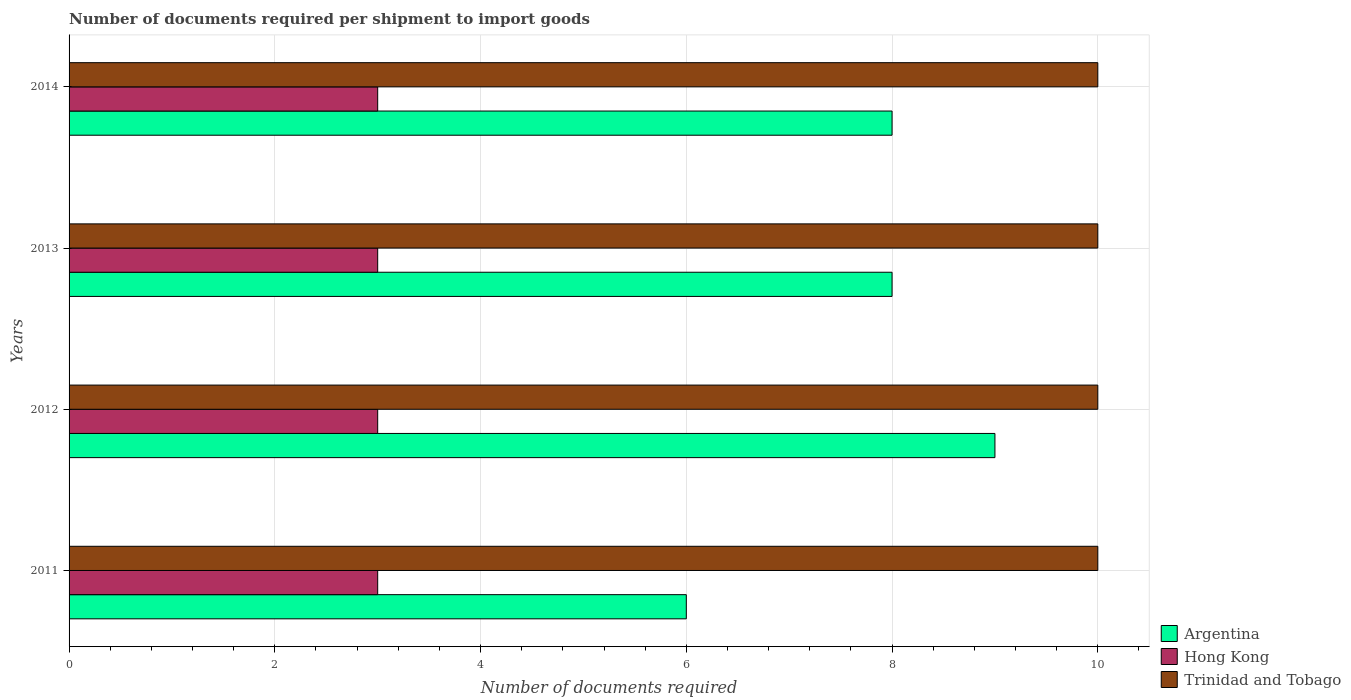How many different coloured bars are there?
Your answer should be compact. 3. Are the number of bars per tick equal to the number of legend labels?
Your answer should be very brief. Yes. Are the number of bars on each tick of the Y-axis equal?
Your answer should be compact. Yes. How many bars are there on the 1st tick from the top?
Your answer should be very brief. 3. In how many cases, is the number of bars for a given year not equal to the number of legend labels?
Offer a very short reply. 0. What is the number of documents required per shipment to import goods in Trinidad and Tobago in 2011?
Provide a succinct answer. 10. Across all years, what is the maximum number of documents required per shipment to import goods in Trinidad and Tobago?
Your answer should be very brief. 10. Across all years, what is the minimum number of documents required per shipment to import goods in Hong Kong?
Make the answer very short. 3. What is the total number of documents required per shipment to import goods in Hong Kong in the graph?
Your answer should be very brief. 12. What is the difference between the number of documents required per shipment to import goods in Hong Kong in 2012 and that in 2014?
Keep it short and to the point. 0. What is the difference between the number of documents required per shipment to import goods in Hong Kong in 2011 and the number of documents required per shipment to import goods in Argentina in 2012?
Your answer should be compact. -6. In the year 2014, what is the difference between the number of documents required per shipment to import goods in Argentina and number of documents required per shipment to import goods in Hong Kong?
Your answer should be compact. 5. Is the number of documents required per shipment to import goods in Trinidad and Tobago in 2012 less than that in 2013?
Make the answer very short. No. Is the difference between the number of documents required per shipment to import goods in Argentina in 2012 and 2014 greater than the difference between the number of documents required per shipment to import goods in Hong Kong in 2012 and 2014?
Offer a terse response. Yes. What is the difference between the highest and the lowest number of documents required per shipment to import goods in Trinidad and Tobago?
Offer a terse response. 0. In how many years, is the number of documents required per shipment to import goods in Hong Kong greater than the average number of documents required per shipment to import goods in Hong Kong taken over all years?
Give a very brief answer. 0. Is the sum of the number of documents required per shipment to import goods in Hong Kong in 2011 and 2012 greater than the maximum number of documents required per shipment to import goods in Trinidad and Tobago across all years?
Your response must be concise. No. What does the 1st bar from the bottom in 2011 represents?
Provide a short and direct response. Argentina. Is it the case that in every year, the sum of the number of documents required per shipment to import goods in Trinidad and Tobago and number of documents required per shipment to import goods in Argentina is greater than the number of documents required per shipment to import goods in Hong Kong?
Your answer should be very brief. Yes. Are all the bars in the graph horizontal?
Your answer should be compact. Yes. How are the legend labels stacked?
Your response must be concise. Vertical. What is the title of the graph?
Give a very brief answer. Number of documents required per shipment to import goods. What is the label or title of the X-axis?
Keep it short and to the point. Number of documents required. What is the Number of documents required in Hong Kong in 2011?
Provide a succinct answer. 3. What is the Number of documents required of Argentina in 2012?
Offer a very short reply. 9. What is the Number of documents required in Hong Kong in 2012?
Your response must be concise. 3. What is the Number of documents required in Trinidad and Tobago in 2012?
Keep it short and to the point. 10. What is the Number of documents required in Hong Kong in 2013?
Your answer should be very brief. 3. What is the Number of documents required of Trinidad and Tobago in 2013?
Your answer should be compact. 10. What is the Number of documents required in Argentina in 2014?
Make the answer very short. 8. What is the Number of documents required of Hong Kong in 2014?
Keep it short and to the point. 3. Across all years, what is the maximum Number of documents required of Hong Kong?
Your response must be concise. 3. Across all years, what is the minimum Number of documents required in Argentina?
Offer a terse response. 6. Across all years, what is the minimum Number of documents required of Trinidad and Tobago?
Ensure brevity in your answer.  10. What is the total Number of documents required in Argentina in the graph?
Make the answer very short. 31. What is the total Number of documents required of Hong Kong in the graph?
Offer a terse response. 12. What is the total Number of documents required of Trinidad and Tobago in the graph?
Your response must be concise. 40. What is the difference between the Number of documents required in Hong Kong in 2011 and that in 2012?
Keep it short and to the point. 0. What is the difference between the Number of documents required of Trinidad and Tobago in 2011 and that in 2013?
Your response must be concise. 0. What is the difference between the Number of documents required of Trinidad and Tobago in 2011 and that in 2014?
Offer a terse response. 0. What is the difference between the Number of documents required in Hong Kong in 2012 and that in 2013?
Give a very brief answer. 0. What is the difference between the Number of documents required in Argentina in 2012 and that in 2014?
Keep it short and to the point. 1. What is the difference between the Number of documents required of Hong Kong in 2012 and that in 2014?
Your answer should be very brief. 0. What is the difference between the Number of documents required in Argentina in 2011 and the Number of documents required in Trinidad and Tobago in 2012?
Provide a short and direct response. -4. What is the difference between the Number of documents required of Hong Kong in 2011 and the Number of documents required of Trinidad and Tobago in 2012?
Make the answer very short. -7. What is the difference between the Number of documents required in Argentina in 2011 and the Number of documents required in Hong Kong in 2013?
Your answer should be very brief. 3. What is the difference between the Number of documents required of Argentina in 2011 and the Number of documents required of Trinidad and Tobago in 2013?
Your response must be concise. -4. What is the difference between the Number of documents required of Hong Kong in 2011 and the Number of documents required of Trinidad and Tobago in 2013?
Your response must be concise. -7. What is the difference between the Number of documents required of Argentina in 2011 and the Number of documents required of Trinidad and Tobago in 2014?
Keep it short and to the point. -4. What is the difference between the Number of documents required in Hong Kong in 2011 and the Number of documents required in Trinidad and Tobago in 2014?
Keep it short and to the point. -7. What is the difference between the Number of documents required of Argentina in 2012 and the Number of documents required of Hong Kong in 2013?
Offer a terse response. 6. What is the difference between the Number of documents required in Hong Kong in 2012 and the Number of documents required in Trinidad and Tobago in 2013?
Your answer should be compact. -7. What is the difference between the Number of documents required of Argentina in 2013 and the Number of documents required of Hong Kong in 2014?
Keep it short and to the point. 5. What is the difference between the Number of documents required of Argentina in 2013 and the Number of documents required of Trinidad and Tobago in 2014?
Your response must be concise. -2. What is the average Number of documents required in Argentina per year?
Provide a succinct answer. 7.75. In the year 2011, what is the difference between the Number of documents required in Argentina and Number of documents required in Hong Kong?
Your response must be concise. 3. In the year 2011, what is the difference between the Number of documents required in Argentina and Number of documents required in Trinidad and Tobago?
Offer a very short reply. -4. In the year 2012, what is the difference between the Number of documents required in Argentina and Number of documents required in Trinidad and Tobago?
Give a very brief answer. -1. In the year 2014, what is the difference between the Number of documents required in Argentina and Number of documents required in Trinidad and Tobago?
Give a very brief answer. -2. In the year 2014, what is the difference between the Number of documents required of Hong Kong and Number of documents required of Trinidad and Tobago?
Ensure brevity in your answer.  -7. What is the ratio of the Number of documents required of Argentina in 2011 to that in 2012?
Your response must be concise. 0.67. What is the ratio of the Number of documents required in Hong Kong in 2011 to that in 2012?
Your answer should be very brief. 1. What is the ratio of the Number of documents required in Argentina in 2011 to that in 2013?
Your response must be concise. 0.75. What is the ratio of the Number of documents required of Trinidad and Tobago in 2011 to that in 2013?
Give a very brief answer. 1. What is the ratio of the Number of documents required of Trinidad and Tobago in 2011 to that in 2014?
Provide a short and direct response. 1. What is the ratio of the Number of documents required in Trinidad and Tobago in 2012 to that in 2014?
Your response must be concise. 1. What is the ratio of the Number of documents required in Hong Kong in 2013 to that in 2014?
Offer a very short reply. 1. What is the difference between the highest and the lowest Number of documents required in Argentina?
Ensure brevity in your answer.  3. What is the difference between the highest and the lowest Number of documents required of Hong Kong?
Ensure brevity in your answer.  0. 